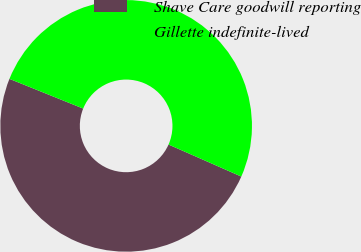Convert chart. <chart><loc_0><loc_0><loc_500><loc_500><pie_chart><fcel>Shave Care goodwill reporting<fcel>Gillette indefinite-lived<nl><fcel>49.5%<fcel>50.5%<nl></chart> 